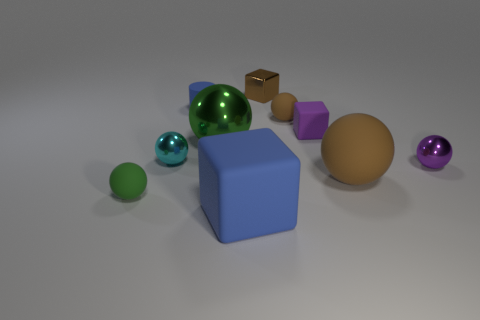There is a block that is the same color as the large rubber sphere; what is its material?
Keep it short and to the point. Metal. What number of brown matte spheres are in front of the tiny shiny sphere right of the small brown matte object?
Your answer should be very brief. 1. There is a metallic thing that is to the left of the blue cylinder; is its size the same as the green rubber thing?
Provide a succinct answer. Yes. How many small brown matte things are the same shape as the cyan metallic object?
Keep it short and to the point. 1. The tiny green object has what shape?
Your answer should be very brief. Sphere. Are there the same number of tiny brown matte objects in front of the purple cube and blue matte cubes?
Offer a terse response. No. Is there anything else that has the same material as the small purple sphere?
Provide a short and direct response. Yes. Are the sphere behind the big green metal thing and the small green ball made of the same material?
Your response must be concise. Yes. Are there fewer matte objects that are to the right of the purple sphere than tiny spheres?
Give a very brief answer. Yes. How many shiny objects are either cyan objects or tiny brown objects?
Ensure brevity in your answer.  2. 